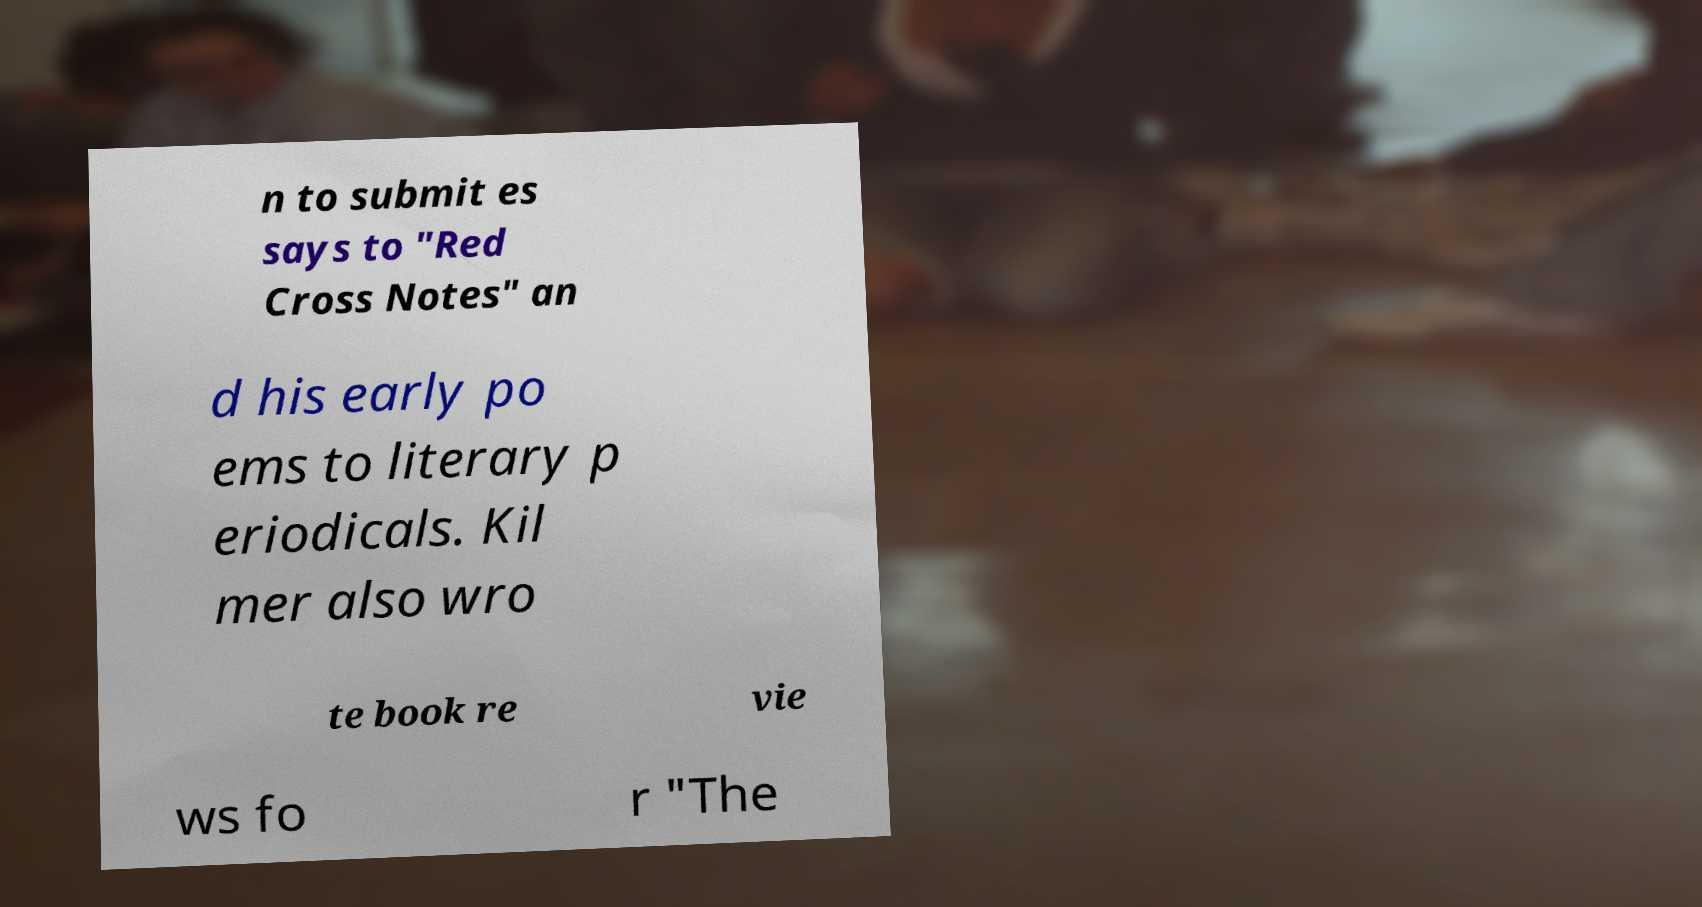Can you accurately transcribe the text from the provided image for me? n to submit es says to "Red Cross Notes" an d his early po ems to literary p eriodicals. Kil mer also wro te book re vie ws fo r "The 